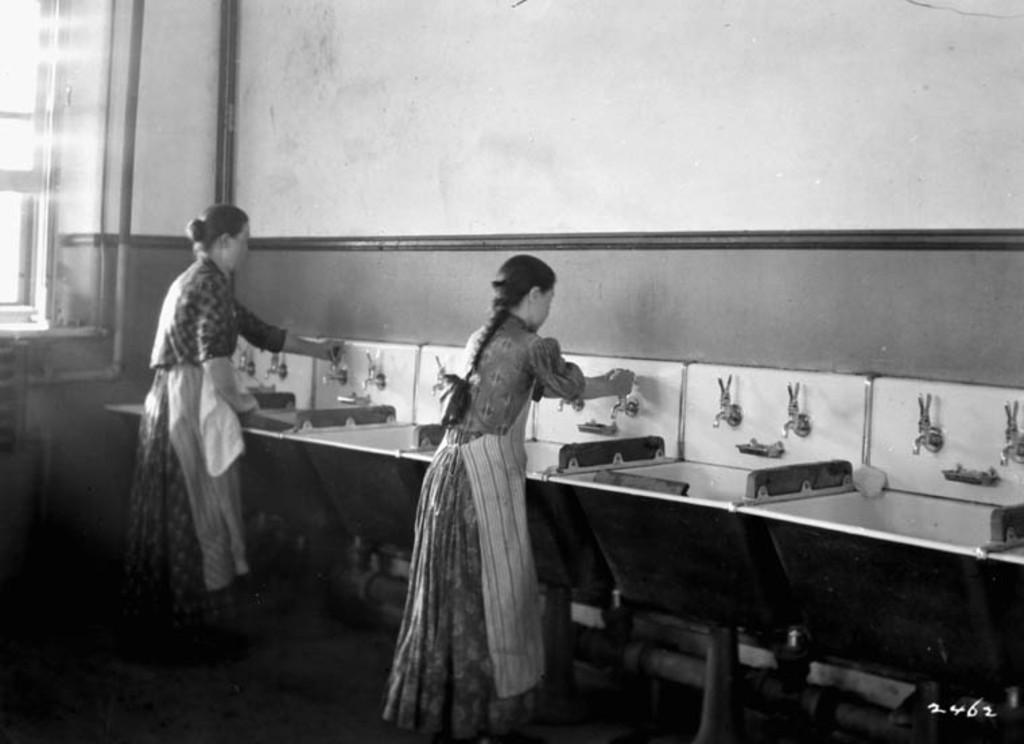How many people are in the image? There are two women standing in the image. What are the women wearing? The women are wearing clothes. What object can be seen in the image that is typically used for washing or cleaning? There is a basin in the image. What feature is present in the image that allows water to flow? There are water taps in the image. What type of architectural element can be seen in the image? There is a wall in the image. What feature in the image allows natural light to enter the space? There is a window in the image. What type of goat can be seen grazing near the window in the image? There is no goat present in the image; it features two women standing near a basin and water taps. How many eggs are visible on the floor in the image? There are no eggs visible on the floor in the image. 